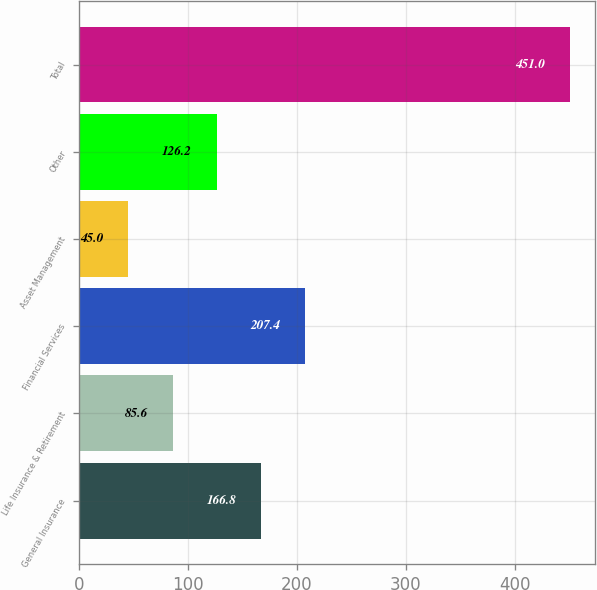Convert chart. <chart><loc_0><loc_0><loc_500><loc_500><bar_chart><fcel>General Insurance<fcel>Life Insurance & Retirement<fcel>Financial Services<fcel>Asset Management<fcel>Other<fcel>Total<nl><fcel>166.8<fcel>85.6<fcel>207.4<fcel>45<fcel>126.2<fcel>451<nl></chart> 